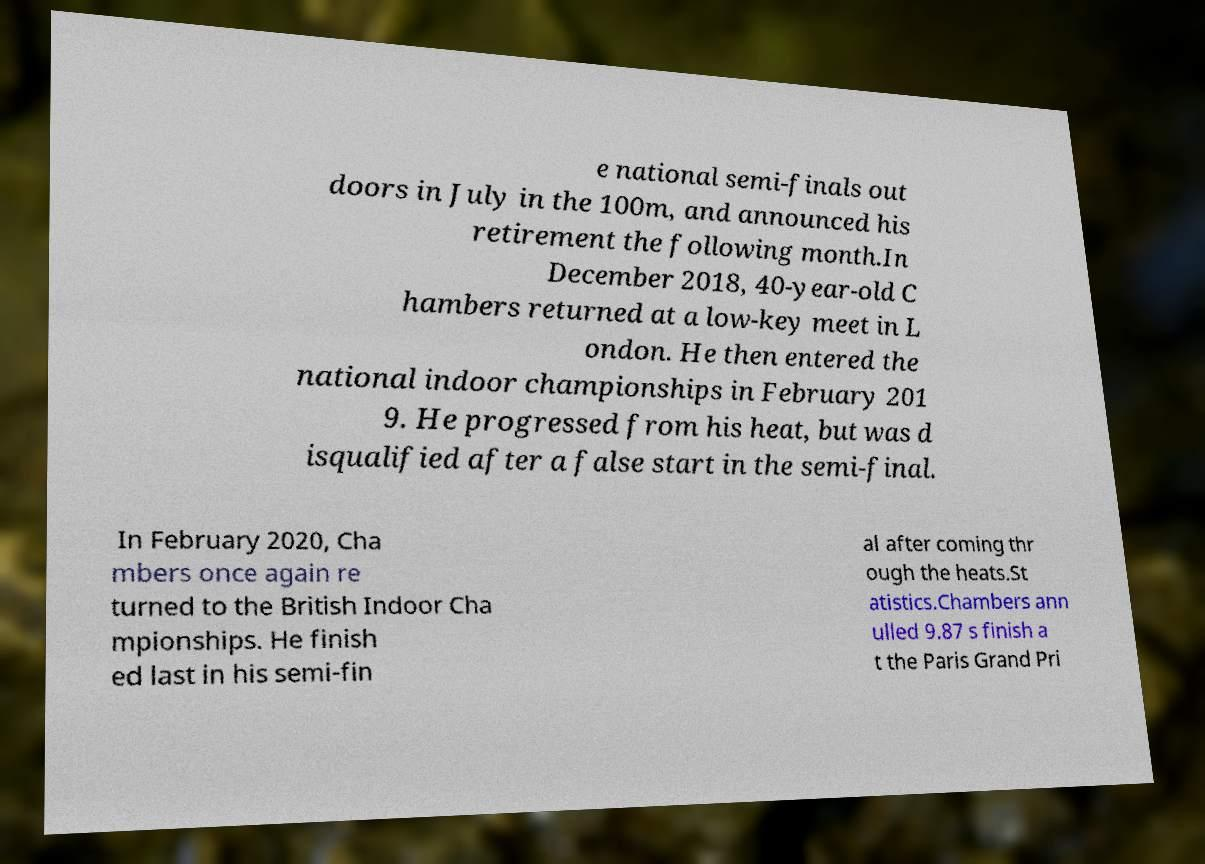For documentation purposes, I need the text within this image transcribed. Could you provide that? e national semi-finals out doors in July in the 100m, and announced his retirement the following month.In December 2018, 40-year-old C hambers returned at a low-key meet in L ondon. He then entered the national indoor championships in February 201 9. He progressed from his heat, but was d isqualified after a false start in the semi-final. In February 2020, Cha mbers once again re turned to the British Indoor Cha mpionships. He finish ed last in his semi-fin al after coming thr ough the heats.St atistics.Chambers ann ulled 9.87 s finish a t the Paris Grand Pri 